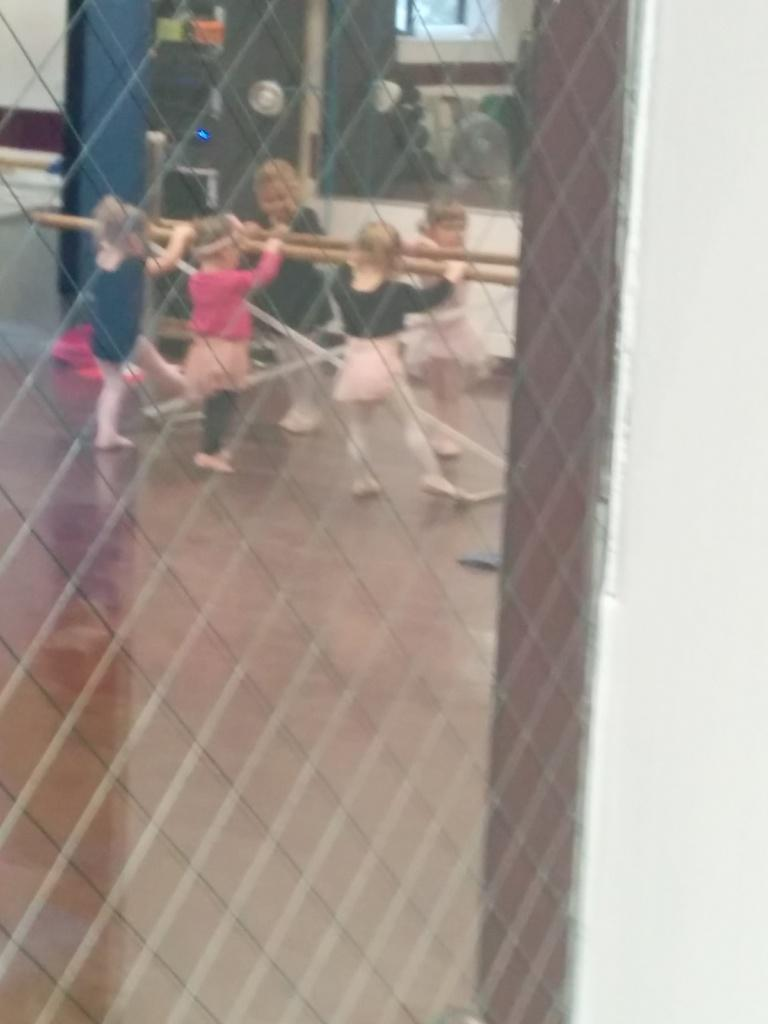What are the kids in the image doing? The kids in the image are playing. What can be seen in the background of the image? There is a window in the image. What is present in the foreground of the image? There is a fence in the image. What type of alarm can be heard going off in the image? There is no alarm present or audible in the image. What impulse might the kids have to jump over the fence in the image? The image does not provide any information about the kids' impulses or motivations for their actions. 